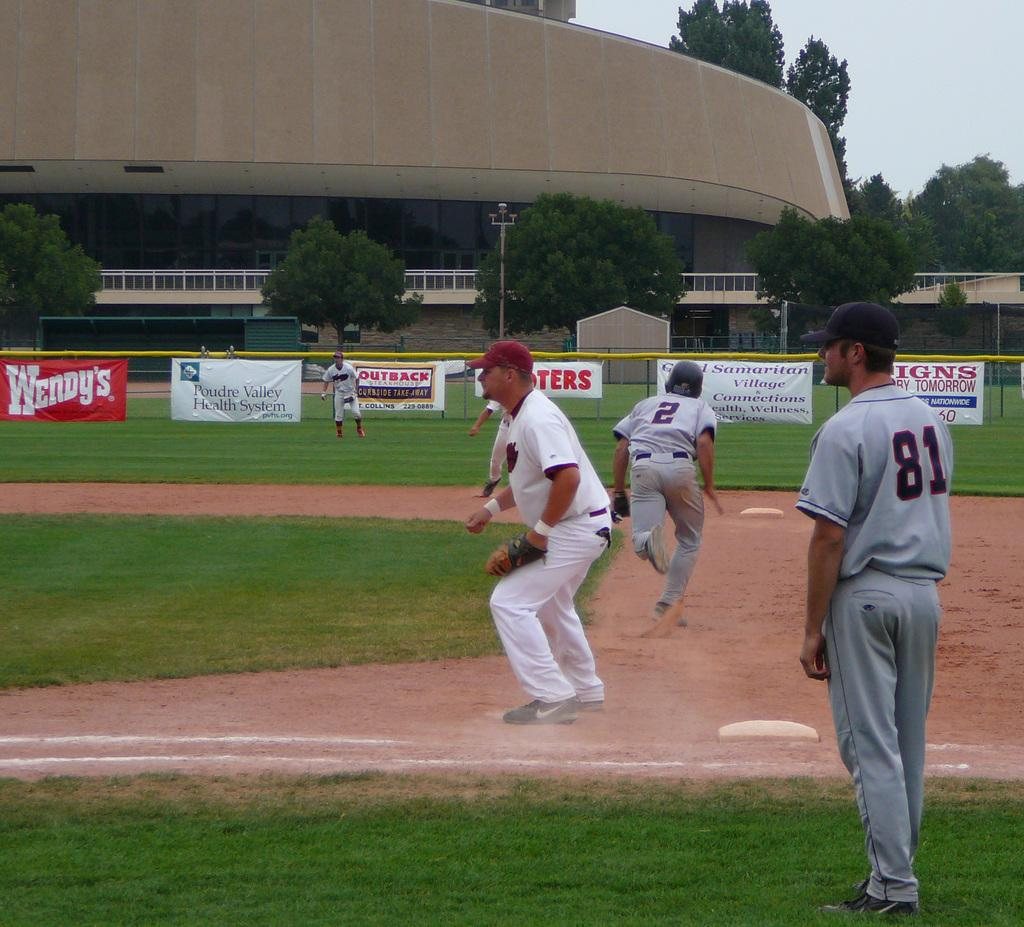<image>
Share a concise interpretation of the image provided. A baseball field with Wendys advertised on the fence. 